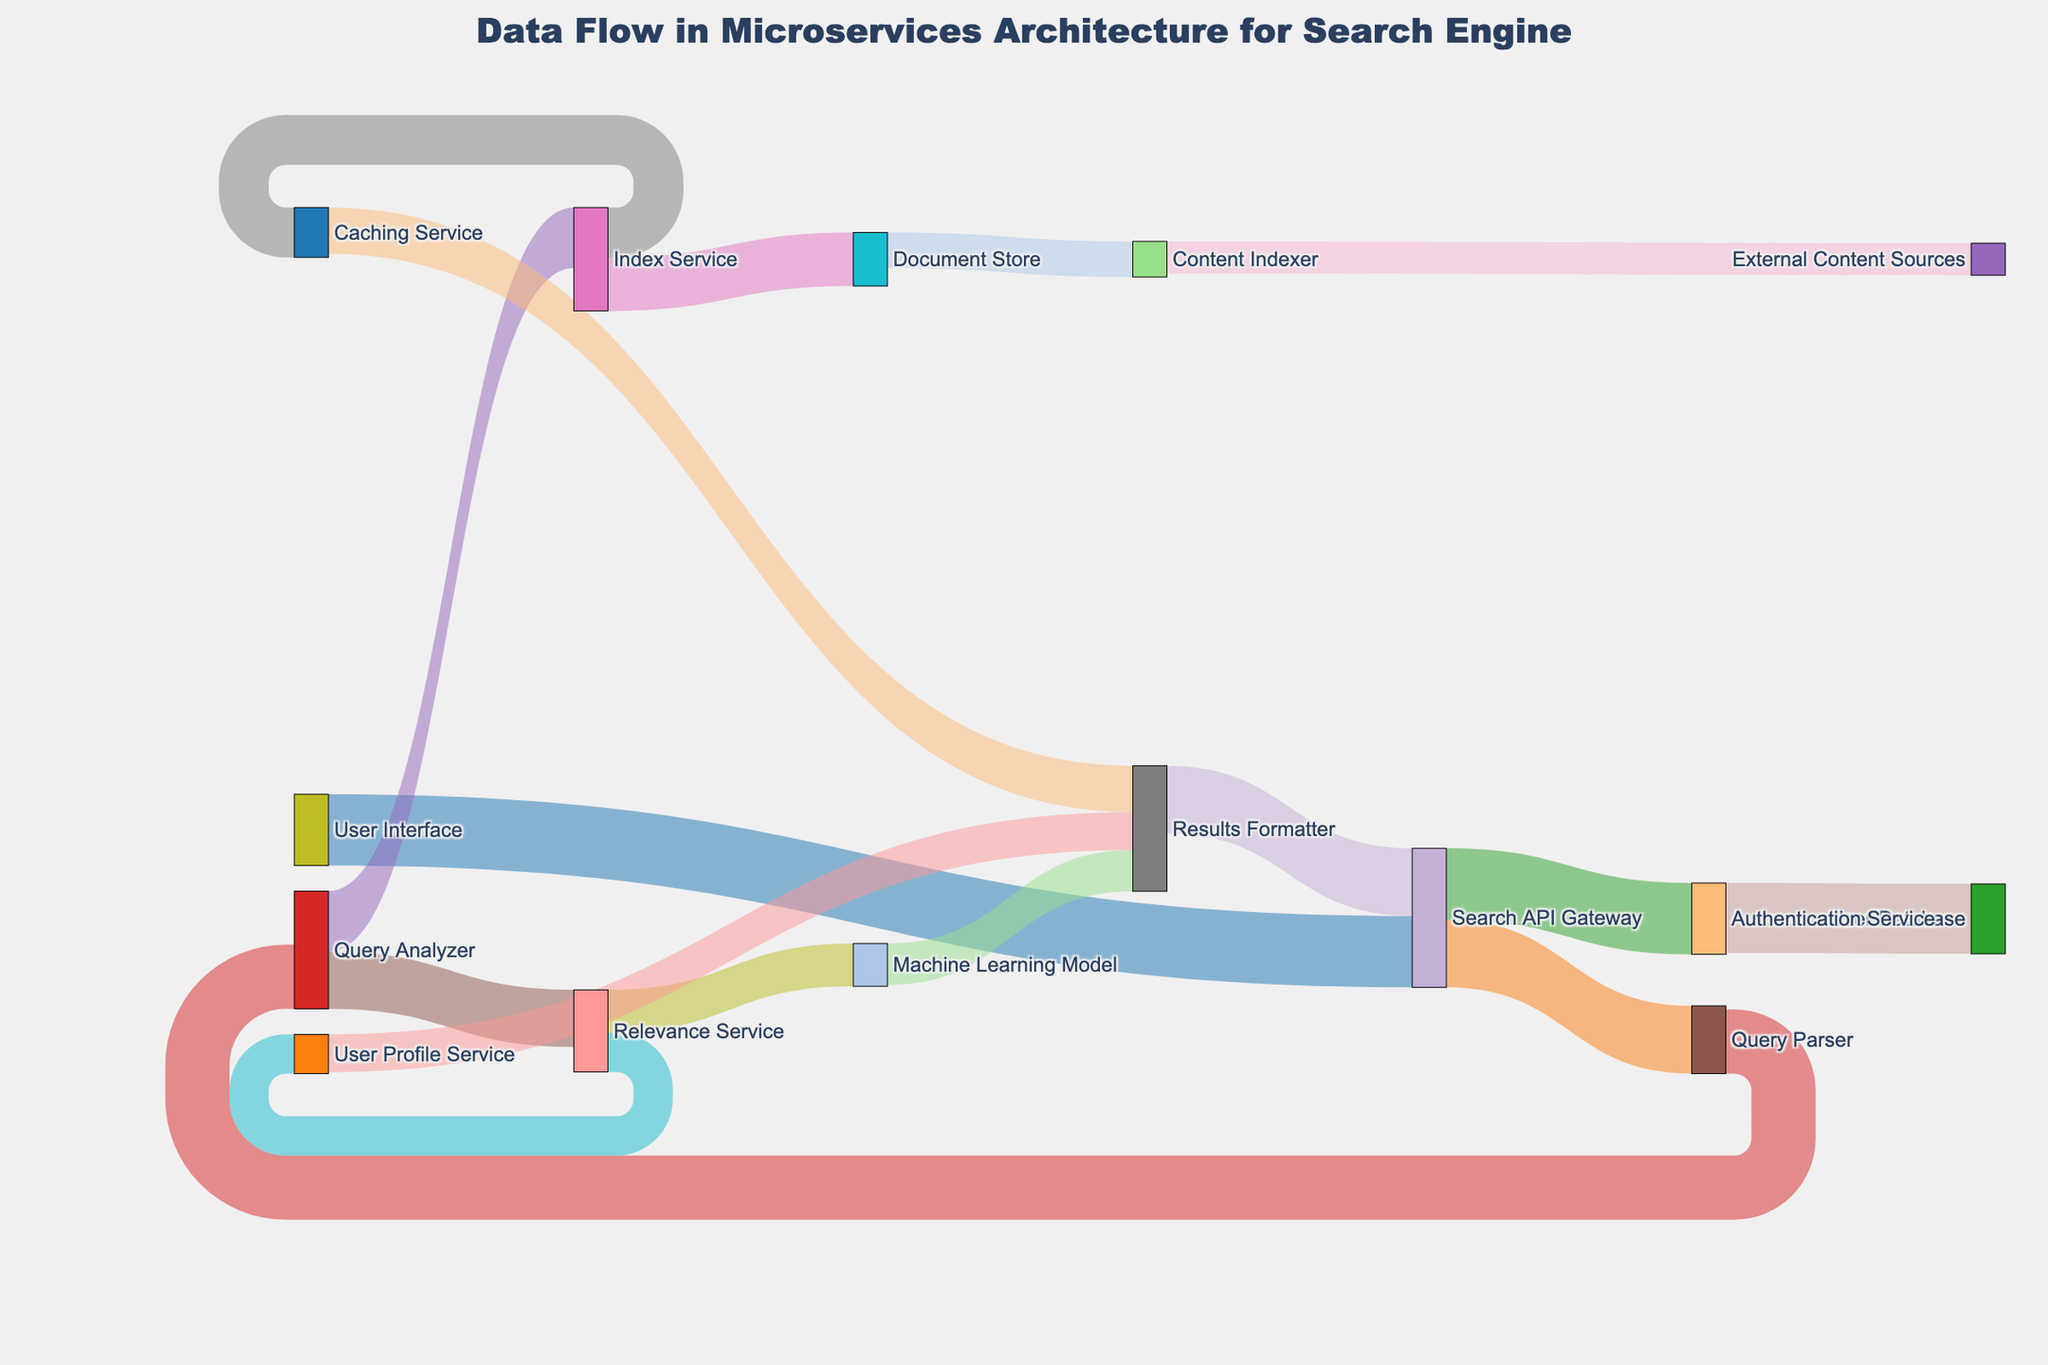What is the title of the diagram? The title is typically found at the top of the figure, providing a summary of what is being displayed.
Answer: Data Flow in Microservices Architecture for Search Engine Which service has the highest incoming request volume? By looking at the links and their associated values, we identify which target has the highest value link leading to it. The Authentication Service receives 1,000,000 requests from the Search API Gateway.
Answer: Authentication Service Which service sends the most requests to the Results Formatter? The Results Formatter receives data from Caching Service, Machine Learning Model, and User Profile Service. The Caching Service sends 650,000 requests, which is the highest.
Answer: Caching Service How many requests are processed by the Query Analyzer? By summarizing all the outgoing requests from the Query Analyzer: 850,000 (to Index Service) + 800,000 (to Relevance Service) = 1,650,000.
Answer: 1,650,000 What is the sum of all requests originating from the Relevance Service? Adding the values of outgoing requests: 600,000 (to Machine Learning Model) + 550,000 (to User Profile Service) = 1,150,000.
Answer: 1,150,000 Which service receives data from the Machine Learning Model? The link from the Machine Learning Model, going to the Results Formatter, shows that it is the target receiving data.
Answer: Results Formatter What's the total number of outgoing requests from the Index Service? The Index Service sends 750,000 requests to Document Store and 700,000 to Caching Service, totaling 1,450,000 requests.
Answer: 1,450,000 How many unique services are represented in the diagram? By counting all unique nodes, we determine there are 17 unique services depicted.
Answer: 17 Which service analyzes the queries received? The Query Analyzer has incoming requests from the Query Parser (900,000), indicating it is responsible for analyzing queries.
Answer: Query Analyzer What is the combined volume of requests going to the Document Store? As per the diagram, the Document Store only receives requests from the Index Service, which totals to 750,000 requests.
Answer: 750,000 How are User Profiles used in the search engine? From the diagram, the User Profile Service feeds data into the Results Formatter with a volume of 530,000 requests, implying User Profiles are used to format search results.
Answer: To format search results 